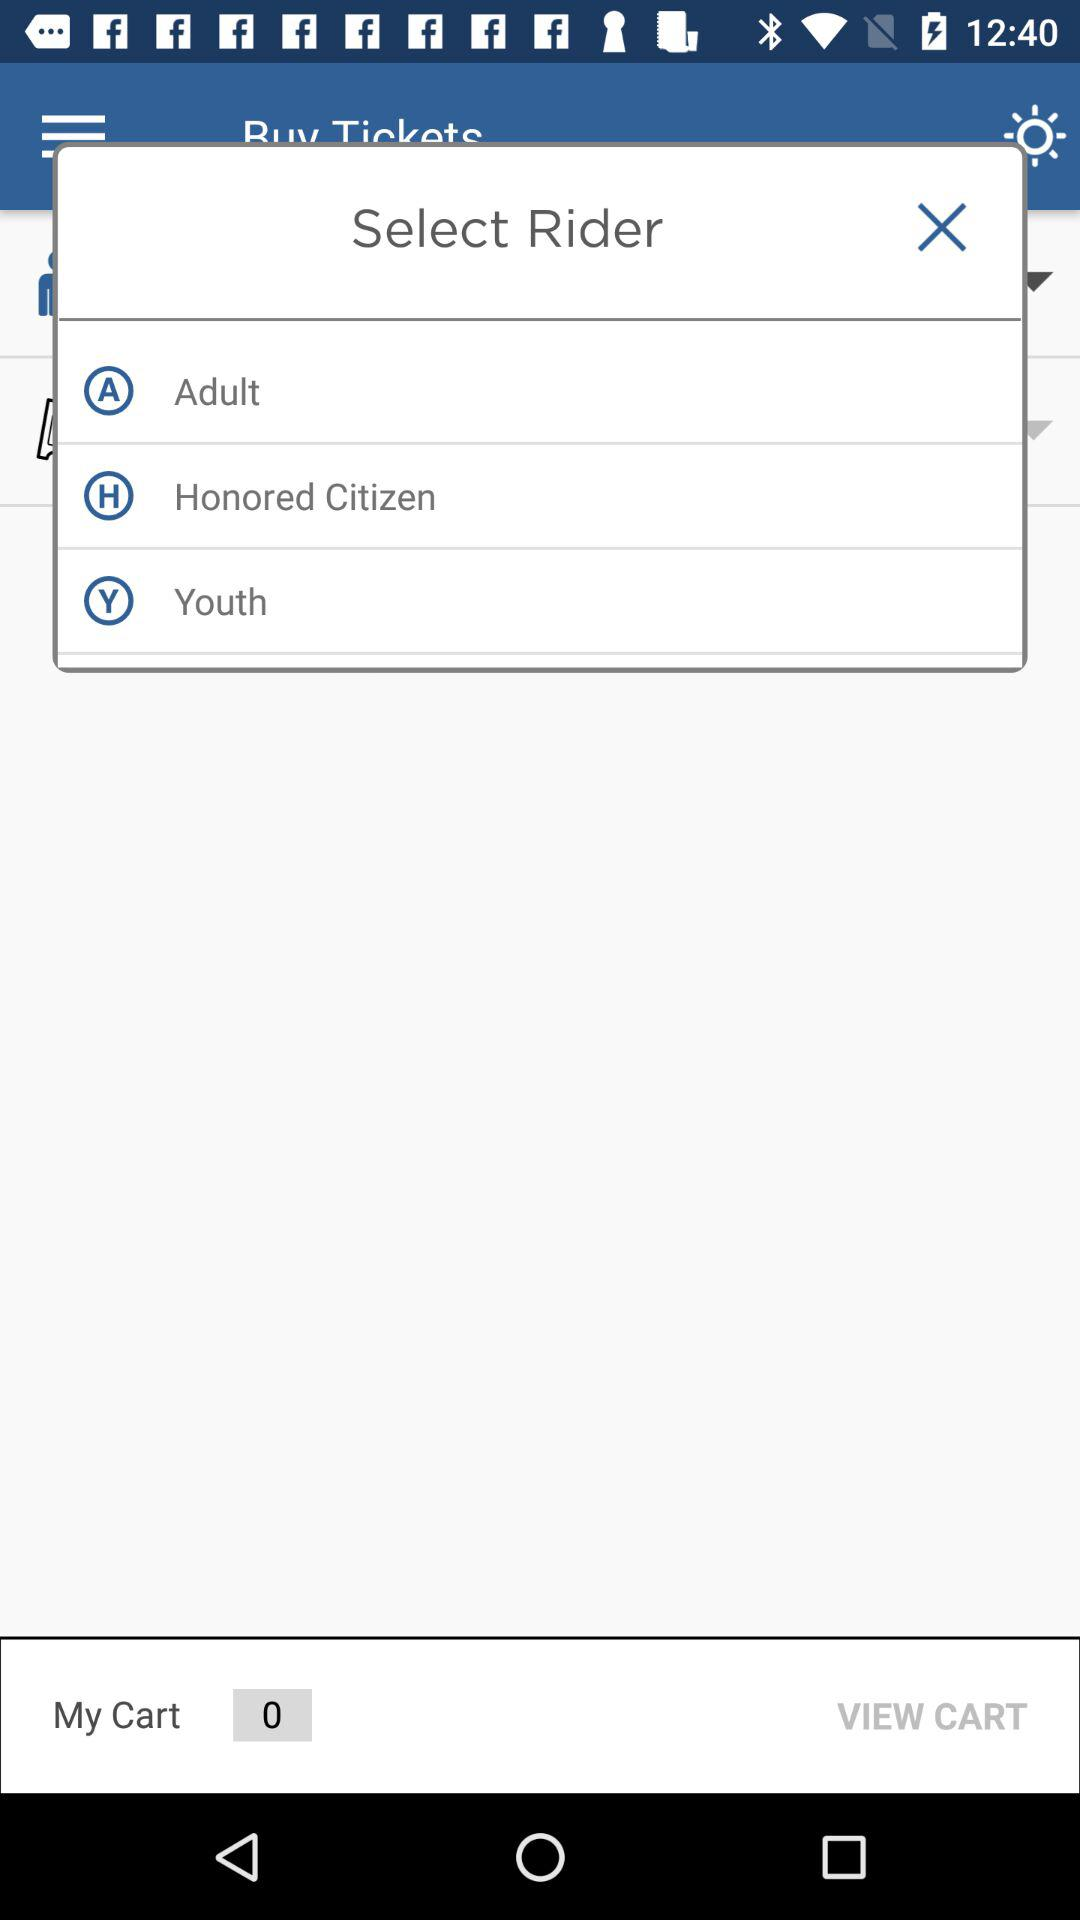What are the given options for the riders? The given options are "Adult", "Honored Citizen" and "Youth". 